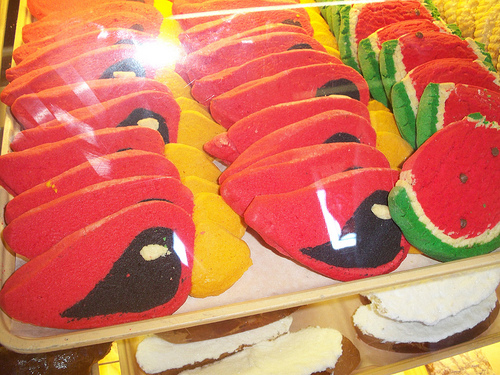<image>
Is the cookie on the tray? Yes. Looking at the image, I can see the cookie is positioned on top of the tray, with the tray providing support. 